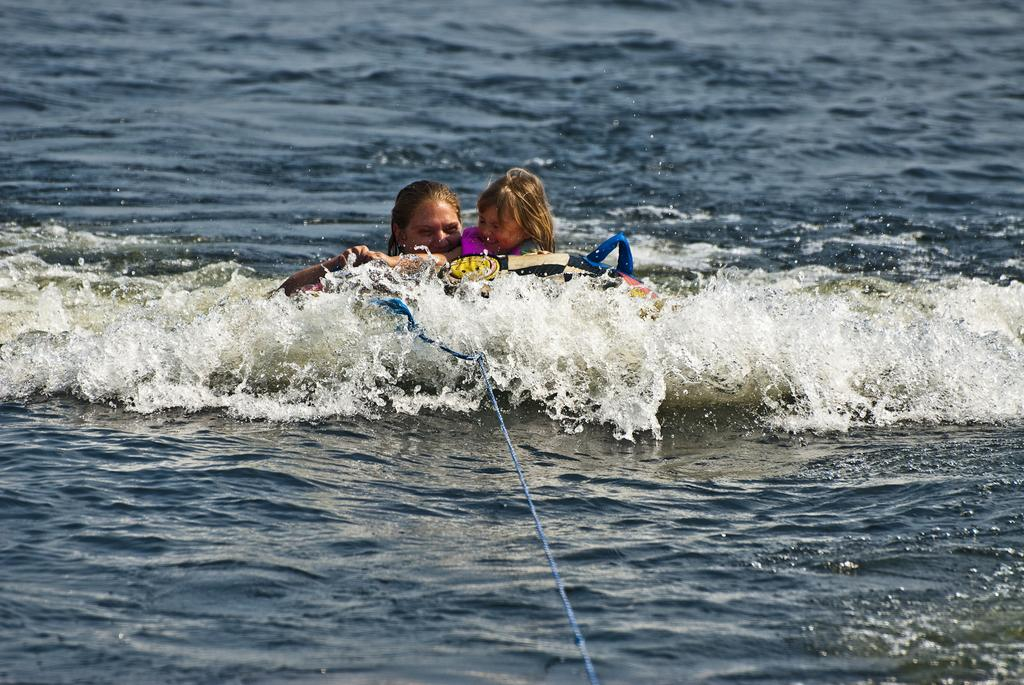Who are the people in the image? There is a lady and a girl in the image. What are the lady and the girl doing in the image? Both the lady and the girl are surfing on the water surface. What can be seen in the image that might be related to surfing? There is a rope in the image, which could be used for surfing. What type of cake is being served to the lady and the girl in the image? There is no cake present in the image; the lady and the girl are surfing on the water surface. Who has the authority to control the light in the image? There is no mention of light or authority in the image, as it focuses on the lady and the girl surfing. 